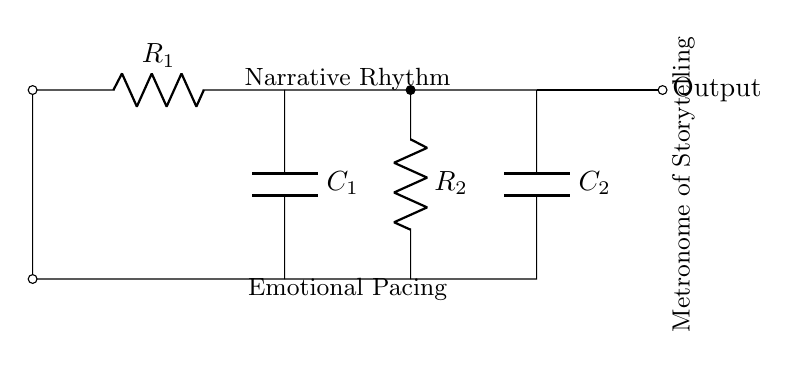What are the components in this circuit? The circuit contains two resistors (R1 and R2) and two capacitors (C1 and C2). They are clearly labeled in the diagram with their respective symbols.
Answer: Resistor, Capacitor What is the output of the circuit? The output is indicated as being at the rightmost side of the circuit diagram, labeled simply as 'Output'. This suggests that the output signifies the function of the oscillator in the context of the circuit.
Answer: Output What is the role of R1 in this circuit? R1, being part of the resistor-capacitor oscillator configuration, influences the charging and discharging times of the connected capacitor. This relationship helps determine the frequency of oscillation.
Answer: Time constant What happens to the frequency if R2 is increased? Increasing R2 would increase the total resistance in the circuit, which would lengthen the time it takes for the capacitors to charge and discharge. Consequently, the frequency of the output oscillation would decrease.
Answer: Decreases How does this circuit illustrate emotional pacing? The connections and designation of 'Emotional Pacing' suggest that the timing of the oscillation can symbolize pacing in a narrative, connecting each beat to emotional rhythm in storytelling.
Answer: Through oscillation timing What is the significance of C1 in this arrangement? C1 directly affects the charge-discharge cycle, contributing to the generation of oscillation frequency; it shapes how quickly emotional beats unfold in the narrative, making it crucial for timing.
Answer: Influences timing What is the implication of the labeled "Metronome of Storytelling"? This label implies that the circuit functions as a timing mechanism, akin to a metronome that sets the rhythm for a musical piece, reflecting the role of pacing in the structure of a narrative.
Answer: Sets narrative rhythm 